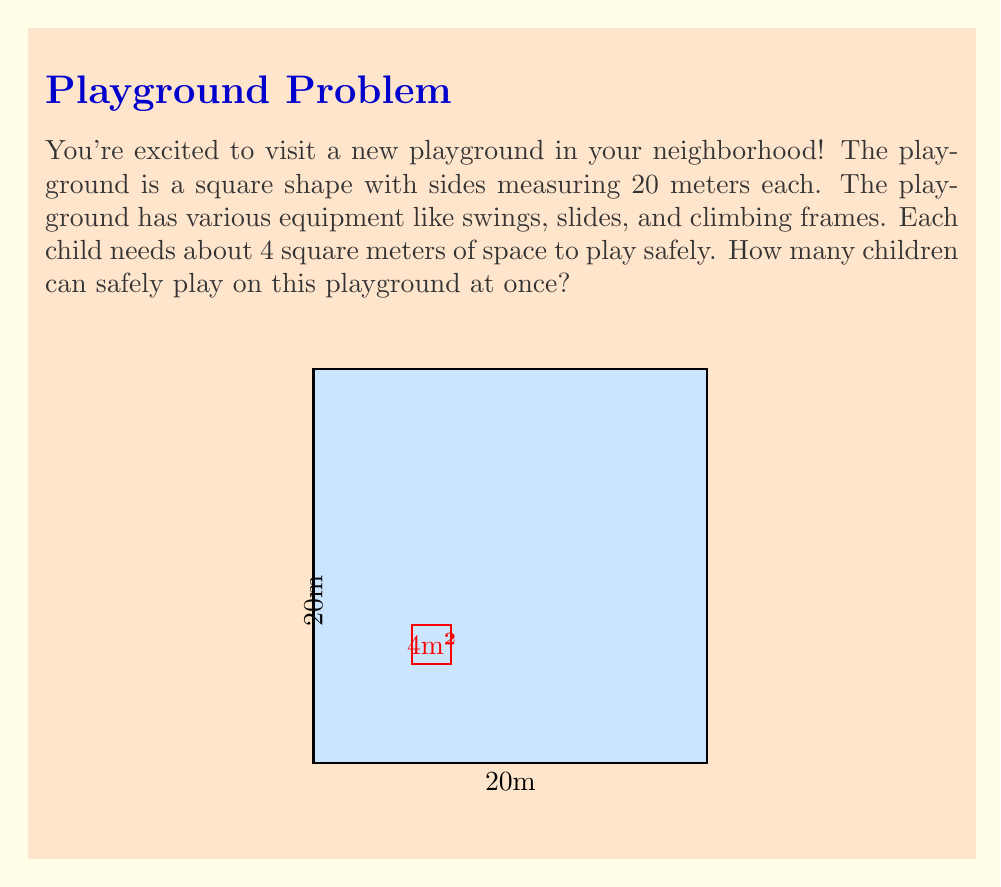Could you help me with this problem? Let's solve this step-by-step:

1) First, we need to calculate the total area of the playground:
   Area = side length × side length
   $$A = 20 \text{ m} \times 20 \text{ m} = 400 \text{ m}^2$$

2) We're told that each child needs about 4 square meters of space:
   $$\text{Space per child} = 4 \text{ m}^2$$

3) To find the number of children that can play safely, we divide the total area by the space needed per child:
   $$\text{Number of children} = \frac{\text{Total area}}{\text{Space per child}}$$

4) Plugging in our values:
   $$\text{Number of children} = \frac{400 \text{ m}^2}{4 \text{ m}^2/\text{child}} = 100 \text{ children}$$

5) However, we need to consider that not all space will be usable due to playground equipment. Let's assume about 20% of the space is taken up by equipment.

6) Usable space:
   $$400 \text{ m}^2 \times 0.8 = 320 \text{ m}^2$$

7) Final calculation:
   $$\text{Number of children} = \frac{320 \text{ m}^2}{4 \text{ m}^2/\text{child}} = 80 \text{ children}$$

Therefore, approximately 80 children can safely play on this playground at once.
Answer: 80 children 